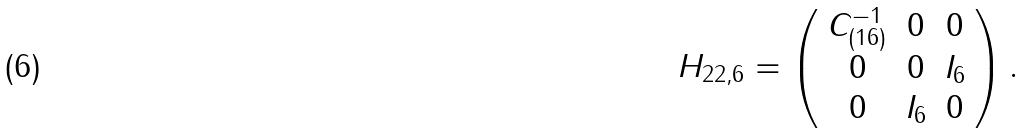<formula> <loc_0><loc_0><loc_500><loc_500>H _ { 2 2 , 6 } = \left ( \begin{array} { c c c } { { C _ { ( 1 6 ) } ^ { - 1 } } } & { 0 } & { 0 } \\ { 0 } & { 0 } & { { I _ { 6 } } } \\ { 0 } & { { I _ { 6 } } } & { 0 } \end{array} \right ) .</formula> 